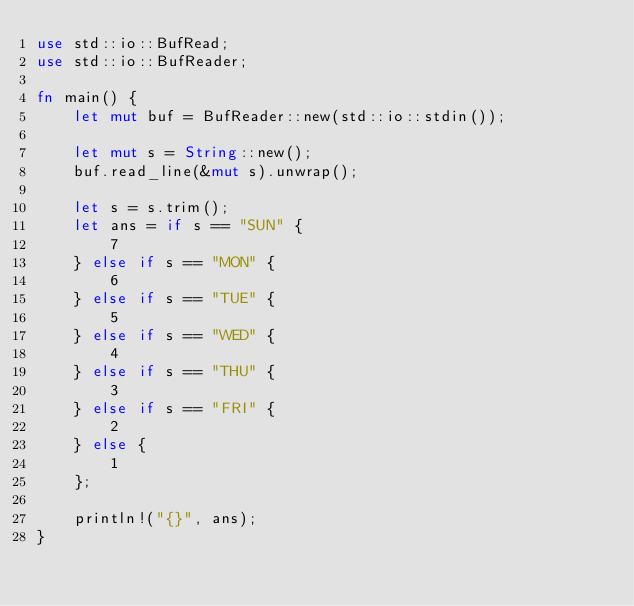Convert code to text. <code><loc_0><loc_0><loc_500><loc_500><_Rust_>use std::io::BufRead;
use std::io::BufReader;

fn main() {
    let mut buf = BufReader::new(std::io::stdin());

    let mut s = String::new();
    buf.read_line(&mut s).unwrap();

    let s = s.trim();
    let ans = if s == "SUN" {
        7
    } else if s == "MON" {
        6
    } else if s == "TUE" {
        5
    } else if s == "WED" {
        4
    } else if s == "THU" {
        3
    } else if s == "FRI" {
        2
    } else {
        1
    };

    println!("{}", ans);
}
</code> 